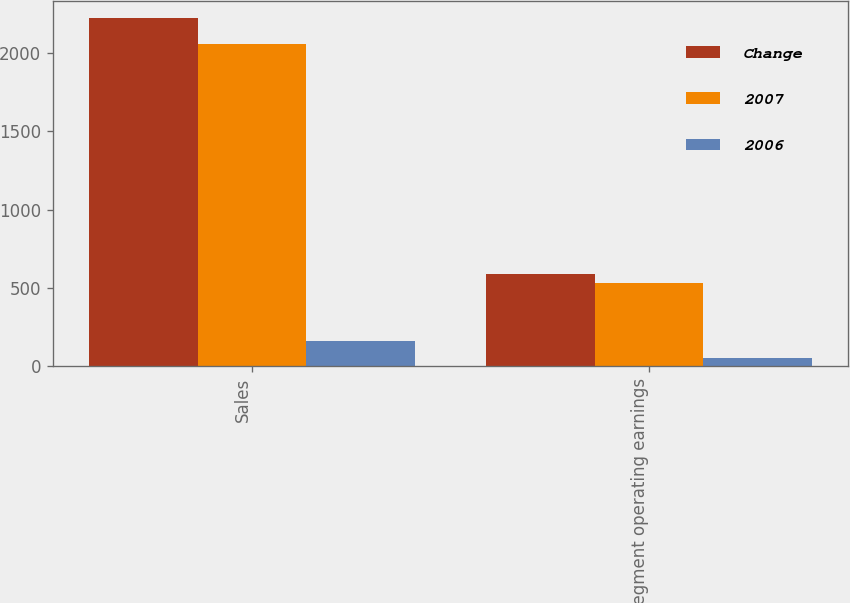<chart> <loc_0><loc_0><loc_500><loc_500><stacked_bar_chart><ecel><fcel>Sales<fcel>Segment operating earnings<nl><fcel>Change<fcel>2221.3<fcel>587.7<nl><fcel>2007<fcel>2059.2<fcel>533.9<nl><fcel>2006<fcel>162.1<fcel>53.8<nl></chart> 